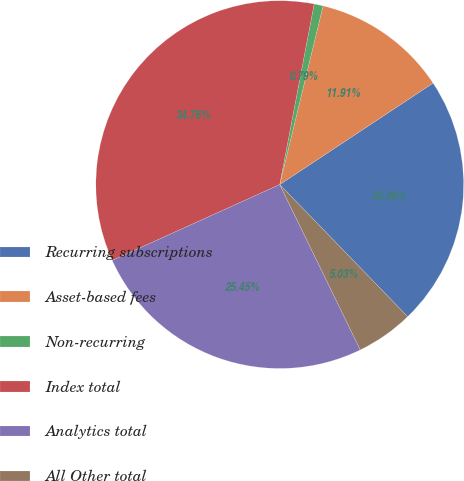Convert chart. <chart><loc_0><loc_0><loc_500><loc_500><pie_chart><fcel>Recurring subscriptions<fcel>Asset-based fees<fcel>Non-recurring<fcel>Index total<fcel>Analytics total<fcel>All Other total<nl><fcel>22.06%<fcel>11.91%<fcel>0.79%<fcel>34.76%<fcel>25.45%<fcel>5.03%<nl></chart> 